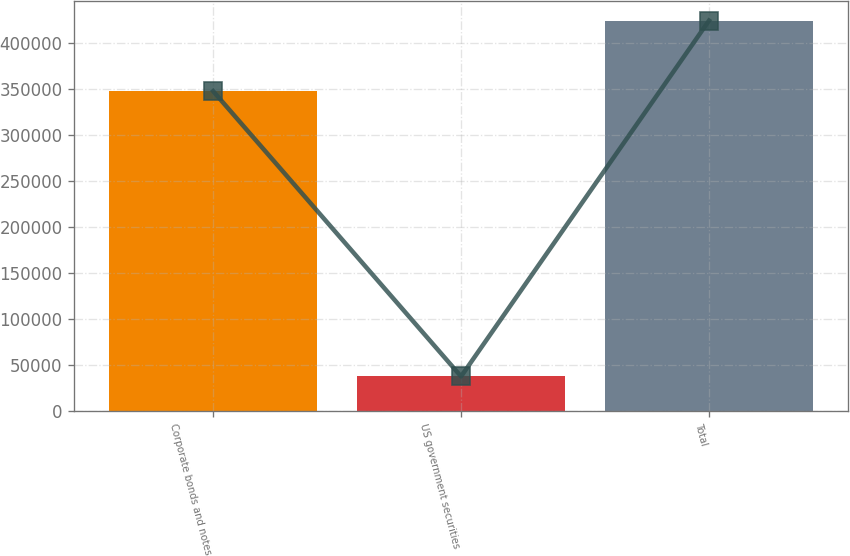Convert chart. <chart><loc_0><loc_0><loc_500><loc_500><bar_chart><fcel>Corporate bonds and notes<fcel>US government securities<fcel>Total<nl><fcel>347360<fcel>37086<fcel>424056<nl></chart> 